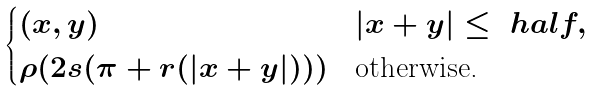<formula> <loc_0><loc_0><loc_500><loc_500>\begin{cases} ( x , y ) & | x + y | \leq \ h a l f , \\ \rho ( 2 s ( \pi + r ( | x + y | ) ) ) & \text {otherwise.} \end{cases}</formula> 